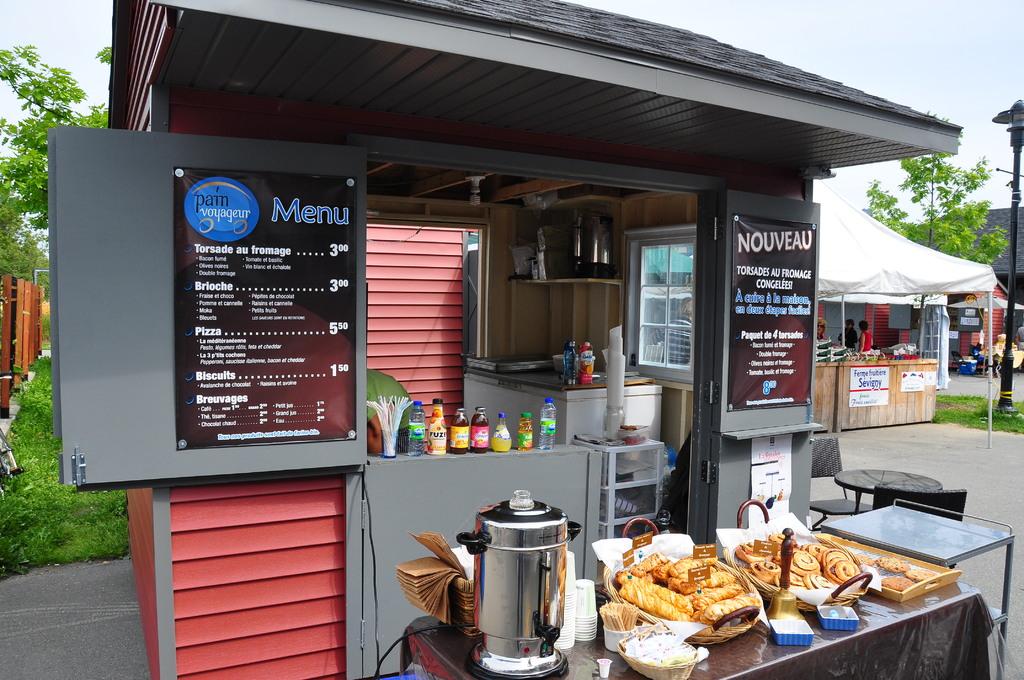What is the sign on the building?
Make the answer very short. Menu. What is written on the sign on the left?
Give a very brief answer. Menu. 